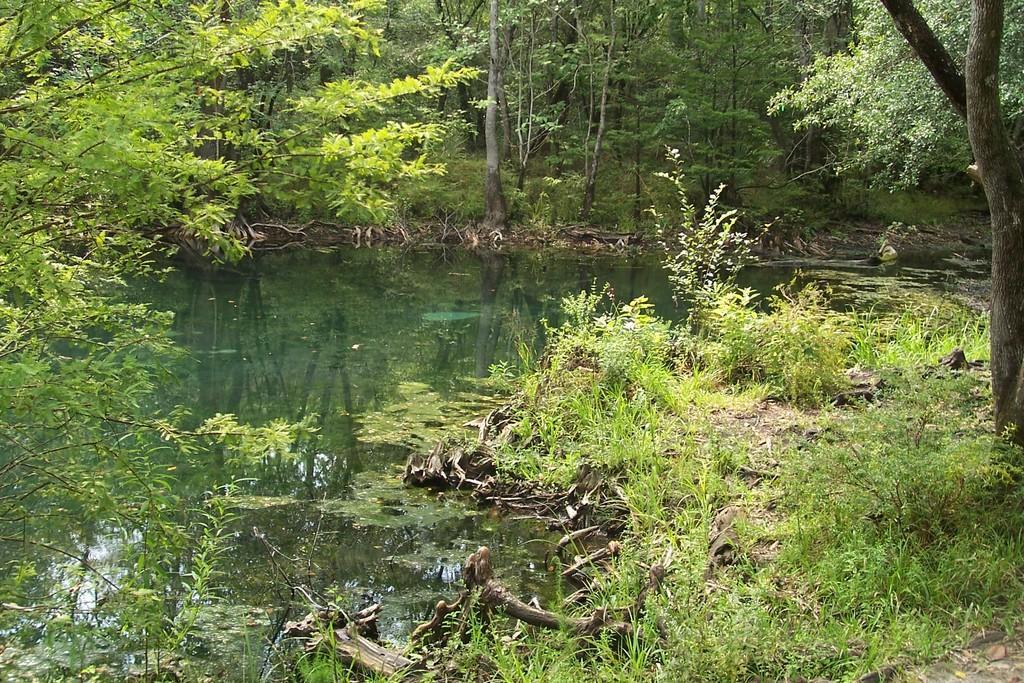How would you summarize this image in a sentence or two? In this picture I can see there is a pond and there are twigs, leaves in the pond. There is grass, plants and trees in the backdrop. 